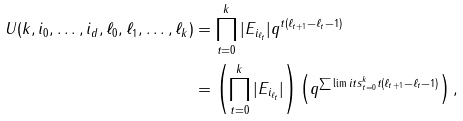Convert formula to latex. <formula><loc_0><loc_0><loc_500><loc_500>U ( k , i _ { 0 } , \dots , i _ { d } , \ell _ { 0 } , \ell _ { 1 } , \dots , \ell _ { k } ) & = \prod _ { t = 0 } ^ { k } | E _ { i _ { \ell _ { t } } } | q ^ { t ( \ell _ { t + 1 } - \ell _ { t } - 1 ) } \\ & = \left ( \prod _ { t = 0 } ^ { k } | E _ { i _ { \ell _ { t } } } | \right ) \left ( q ^ { \sum \lim i t s _ { t = 0 } ^ { k } t ( \ell _ { t + 1 } - \ell _ { t } - 1 ) } \right ) ,</formula> 